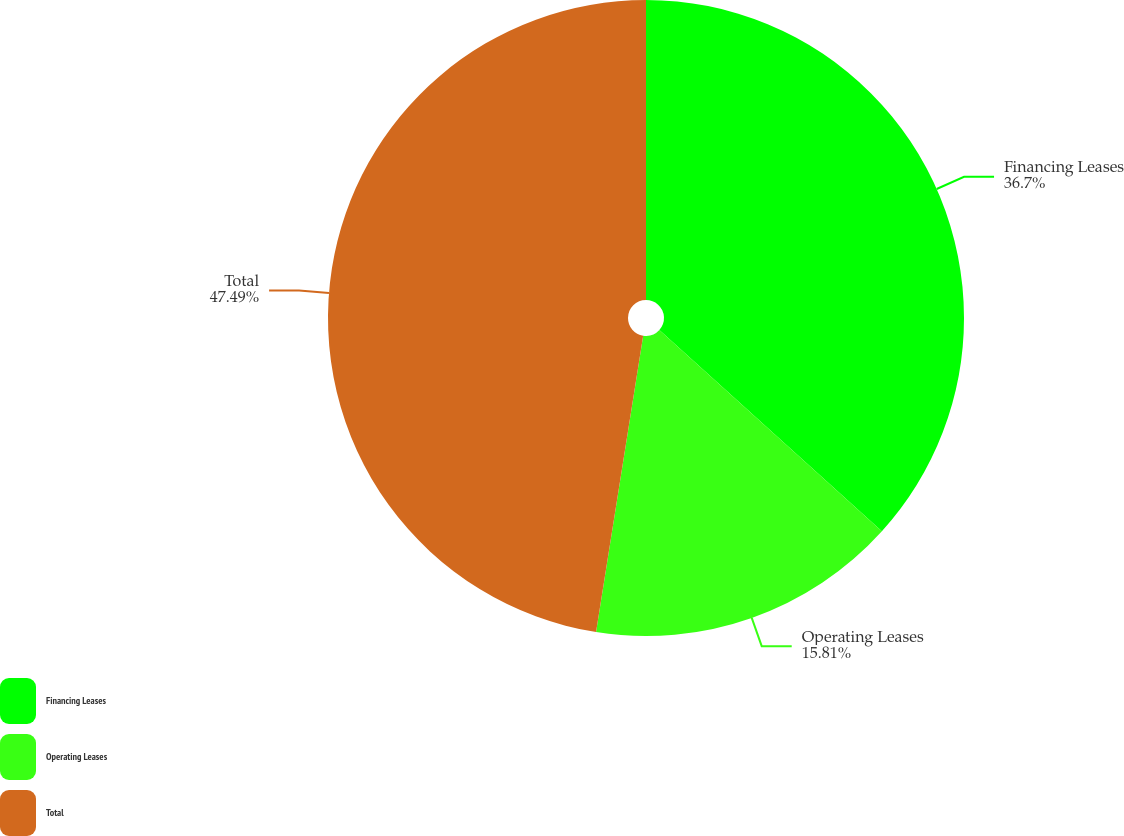<chart> <loc_0><loc_0><loc_500><loc_500><pie_chart><fcel>Financing Leases<fcel>Operating Leases<fcel>Total<nl><fcel>36.7%<fcel>15.81%<fcel>47.49%<nl></chart> 